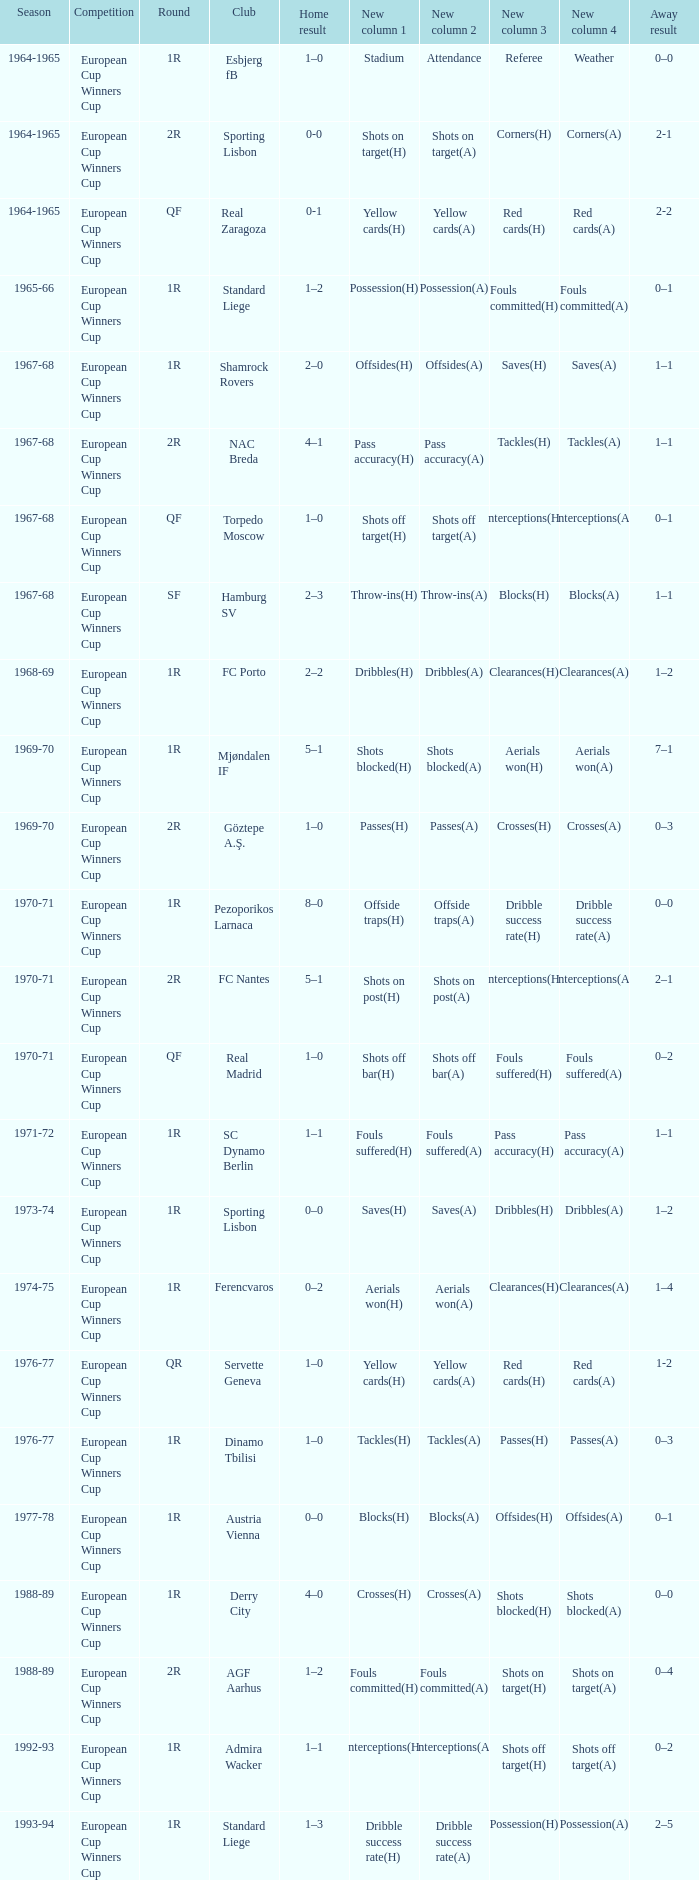Home result of 1–0, and a Away result of 0–1 involves what club? Torpedo Moscow. 